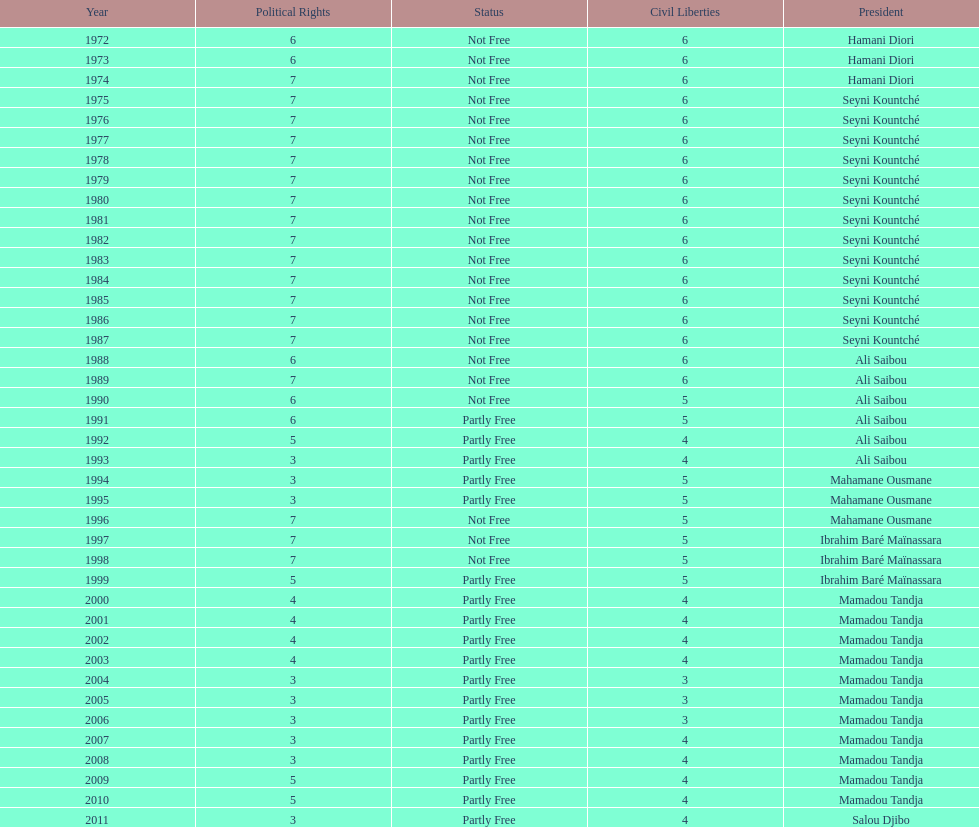Who ruled longer, ali saibou or mamadou tandja? Mamadou Tandja. 